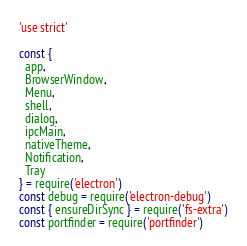<code> <loc_0><loc_0><loc_500><loc_500><_JavaScript_>'use strict'

const {
  app,
  BrowserWindow,
  Menu,
  shell,
  dialog,
  ipcMain,
  nativeTheme,
  Notification,
  Tray
} = require('electron')
const debug = require('electron-debug')
const { ensureDirSync } = require('fs-extra')
const portfinder = require('portfinder')</code> 